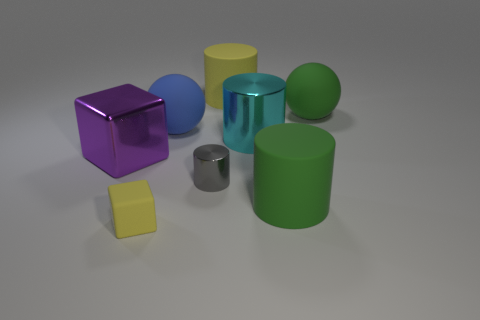Subtract all gray metal cylinders. How many cylinders are left? 3 Subtract all purple cubes. How many cubes are left? 1 Add 1 big green rubber balls. How many objects exist? 9 Subtract all blocks. How many objects are left? 6 Add 2 brown metal cubes. How many brown metal cubes exist? 2 Subtract 0 gray cubes. How many objects are left? 8 Subtract 2 cubes. How many cubes are left? 0 Subtract all red blocks. Subtract all blue cylinders. How many blocks are left? 2 Subtract all cyan balls. How many yellow blocks are left? 1 Subtract all big shiny cubes. Subtract all large yellow rubber cylinders. How many objects are left? 6 